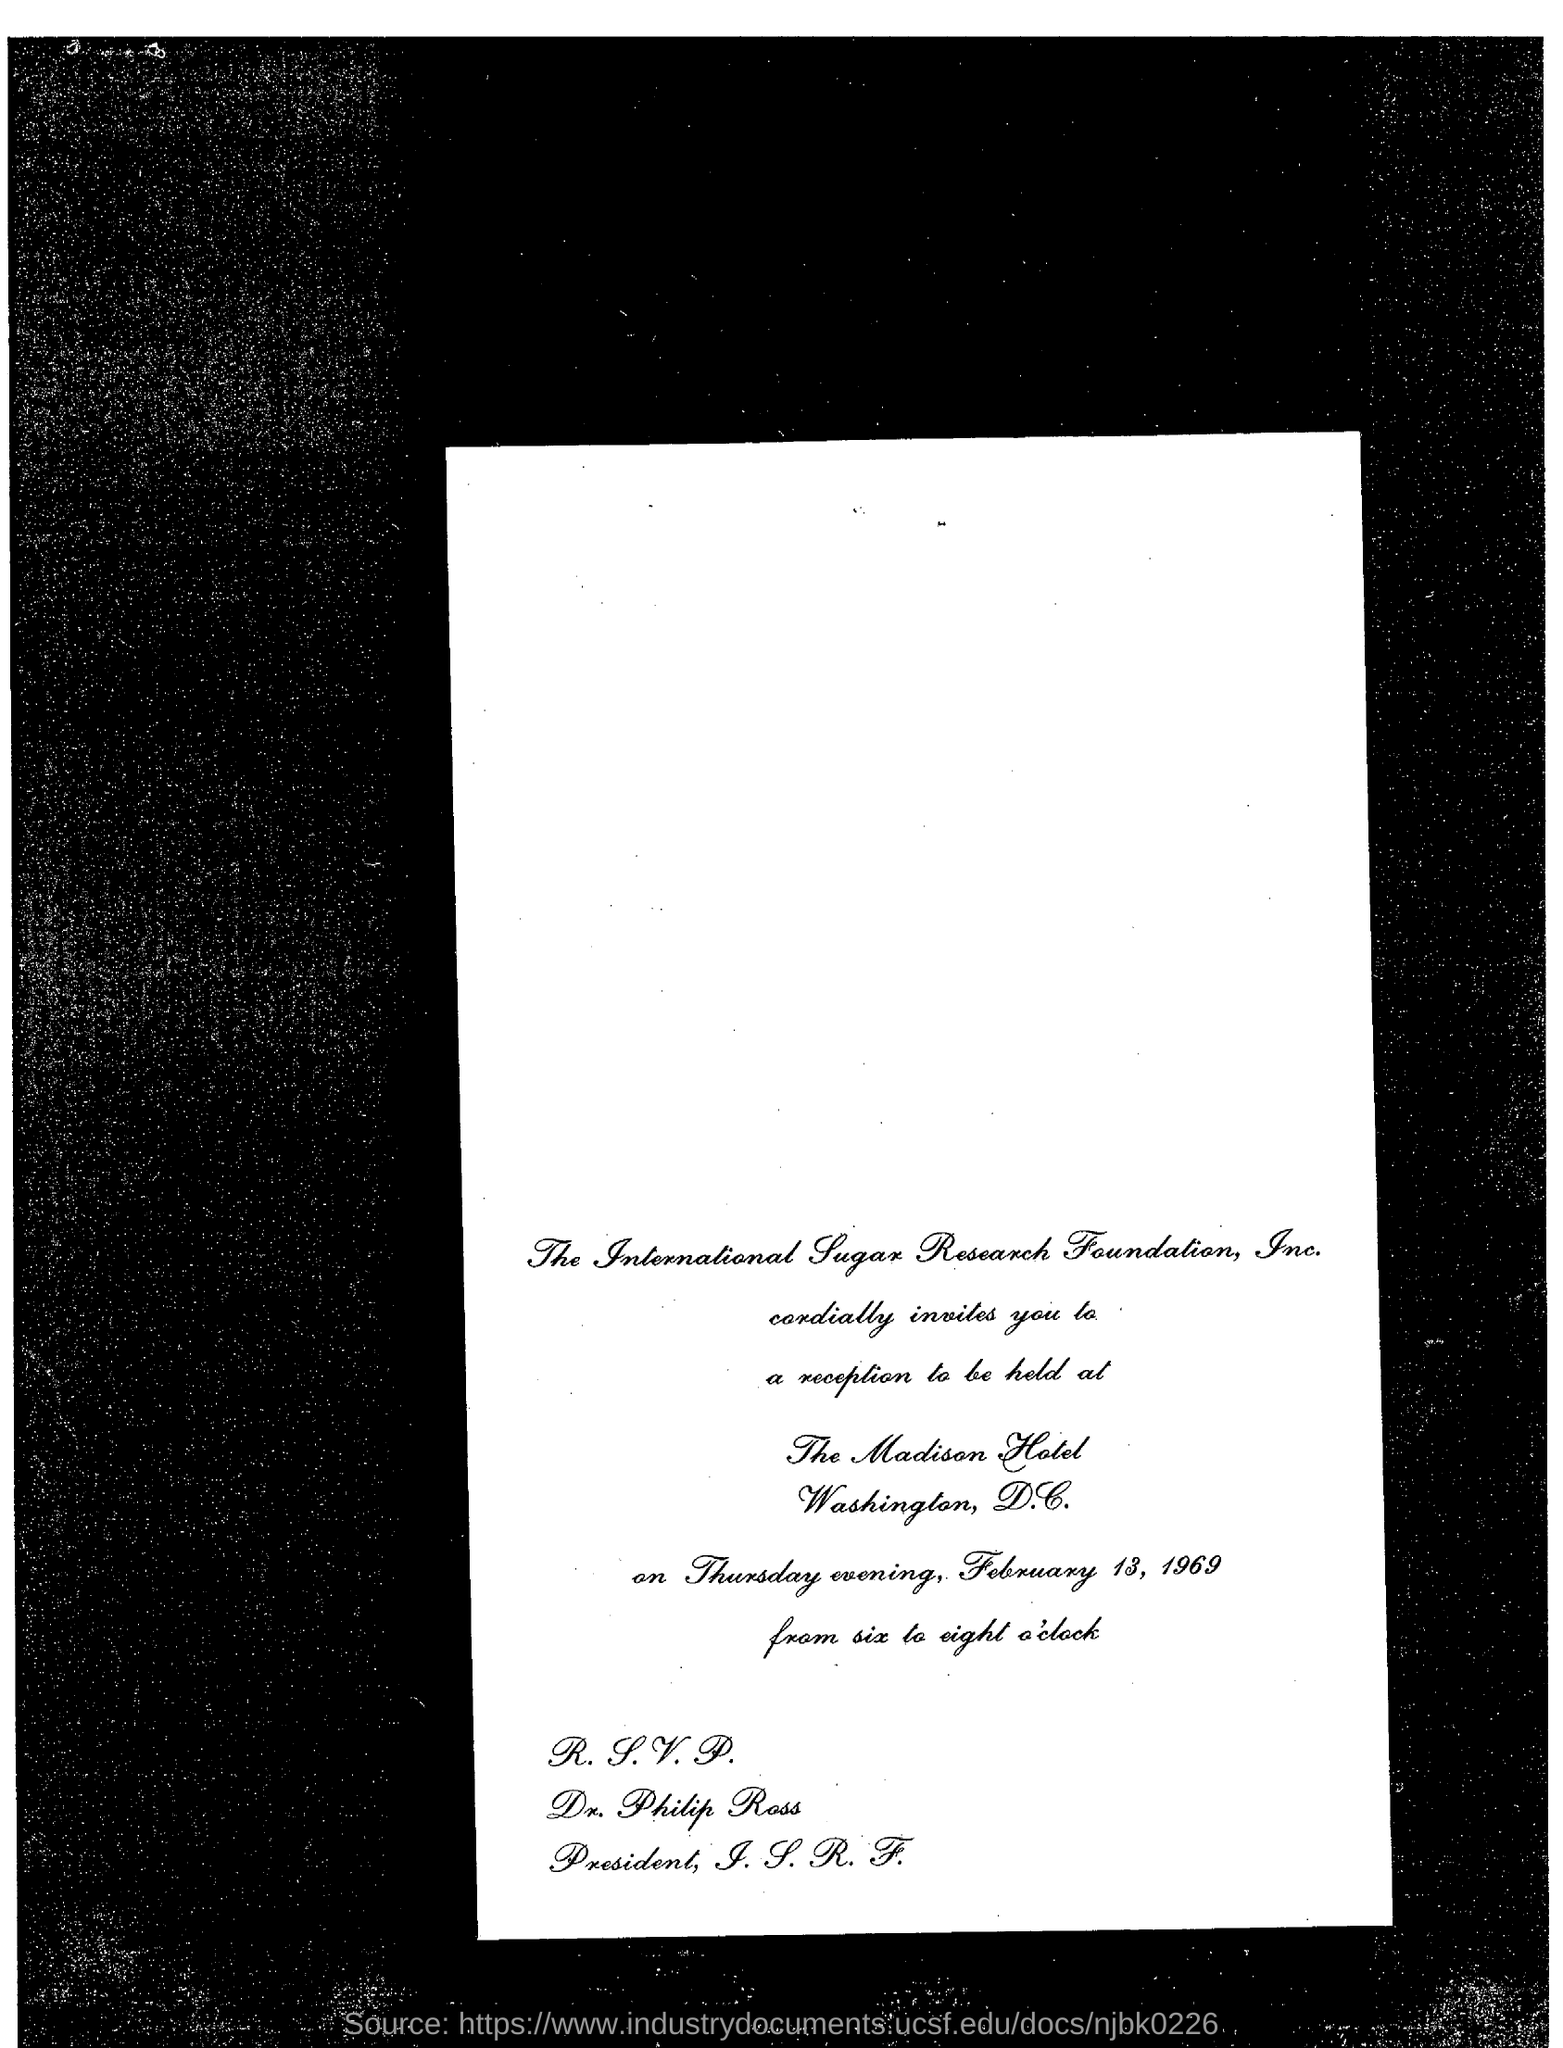Specify some key components in this picture. The location of the reception will be held at the Madison Hotel. The International Sugar Research Foundation, Inc. is the company that is mentioned. 